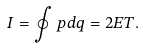Convert formula to latex. <formula><loc_0><loc_0><loc_500><loc_500>I = \oint p d q = 2 E T .</formula> 